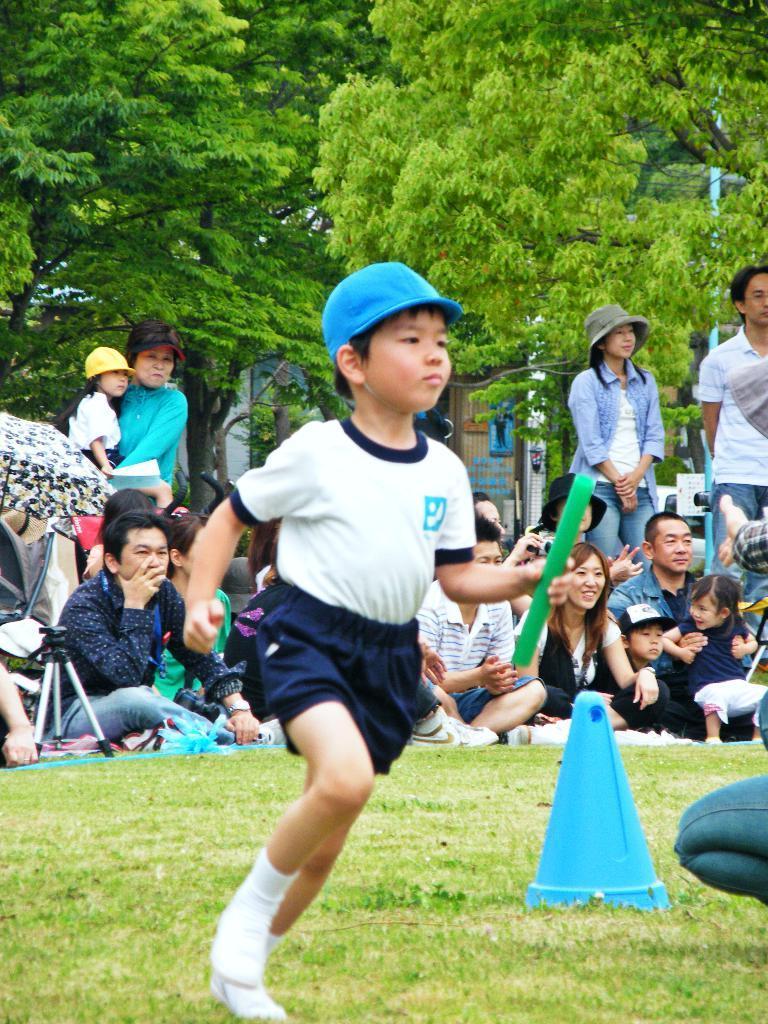Describe this image in one or two sentences. In this image we can see a boy is running, he is wearing white color t-shirt with blue shorts and blue cap. He is holding green color thing in his hand. The land is full grassy. Background of the image people are sitting and standing. Behind the trees are present. Right side of the image one triangular shape object is there. 